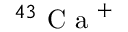<formula> <loc_0><loc_0><loc_500><loc_500>^ { 4 3 } C a ^ { + }</formula> 